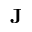Convert formula to latex. <formula><loc_0><loc_0><loc_500><loc_500>J</formula> 